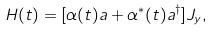<formula> <loc_0><loc_0><loc_500><loc_500>H ( t ) = [ \alpha ( t ) a + \alpha ^ { * } ( t ) a ^ { \dagger } ] J _ { y } ,</formula> 